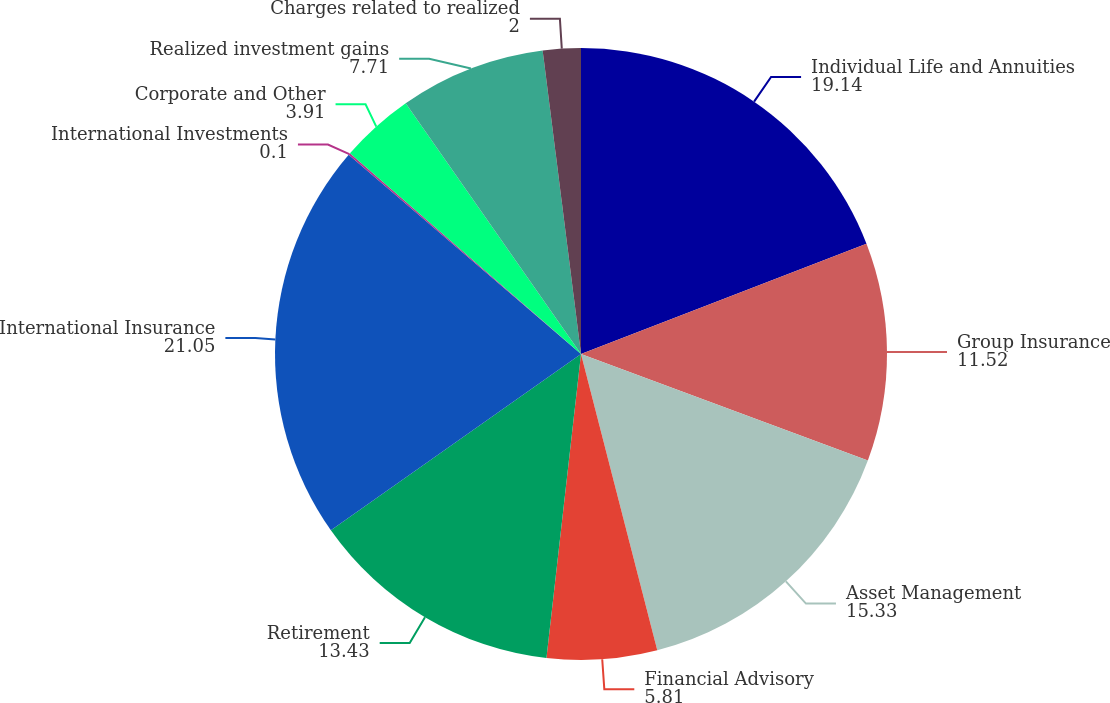Convert chart. <chart><loc_0><loc_0><loc_500><loc_500><pie_chart><fcel>Individual Life and Annuities<fcel>Group Insurance<fcel>Asset Management<fcel>Financial Advisory<fcel>Retirement<fcel>International Insurance<fcel>International Investments<fcel>Corporate and Other<fcel>Realized investment gains<fcel>Charges related to realized<nl><fcel>19.14%<fcel>11.52%<fcel>15.33%<fcel>5.81%<fcel>13.43%<fcel>21.05%<fcel>0.1%<fcel>3.91%<fcel>7.71%<fcel>2.0%<nl></chart> 